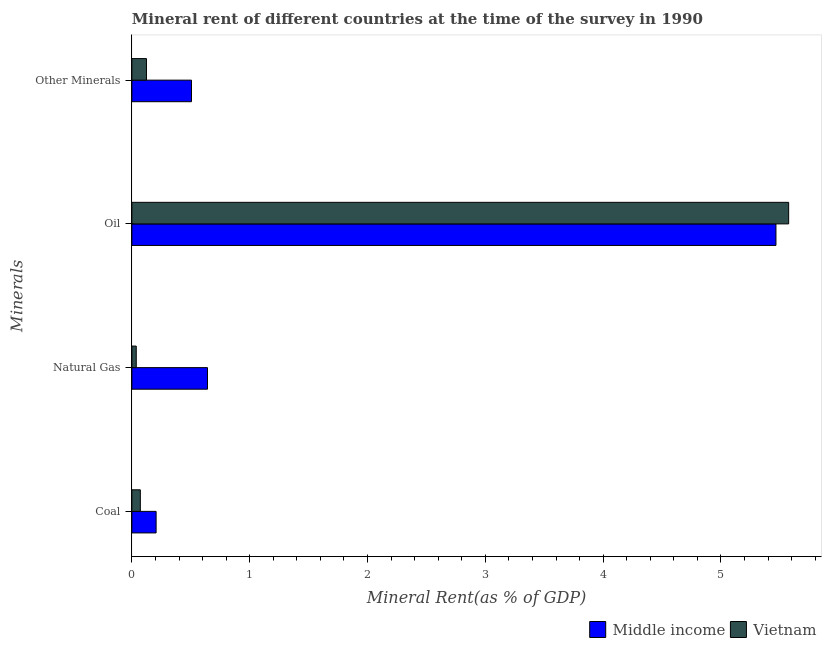Are the number of bars per tick equal to the number of legend labels?
Provide a succinct answer. Yes. Are the number of bars on each tick of the Y-axis equal?
Provide a succinct answer. Yes. What is the label of the 2nd group of bars from the top?
Provide a succinct answer. Oil. What is the  rent of other minerals in Vietnam?
Keep it short and to the point. 0.12. Across all countries, what is the maximum  rent of other minerals?
Your answer should be very brief. 0.51. Across all countries, what is the minimum coal rent?
Ensure brevity in your answer.  0.07. In which country was the coal rent maximum?
Give a very brief answer. Middle income. In which country was the natural gas rent minimum?
Offer a terse response. Vietnam. What is the total coal rent in the graph?
Keep it short and to the point. 0.28. What is the difference between the natural gas rent in Middle income and that in Vietnam?
Make the answer very short. 0.6. What is the difference between the natural gas rent in Middle income and the  rent of other minerals in Vietnam?
Provide a succinct answer. 0.52. What is the average  rent of other minerals per country?
Offer a terse response. 0.31. What is the difference between the  rent of other minerals and oil rent in Middle income?
Offer a terse response. -4.96. What is the ratio of the coal rent in Vietnam to that in Middle income?
Your answer should be very brief. 0.35. Is the coal rent in Middle income less than that in Vietnam?
Keep it short and to the point. No. Is the difference between the oil rent in Middle income and Vietnam greater than the difference between the coal rent in Middle income and Vietnam?
Ensure brevity in your answer.  No. What is the difference between the highest and the second highest oil rent?
Keep it short and to the point. 0.11. What is the difference between the highest and the lowest  rent of other minerals?
Offer a very short reply. 0.38. In how many countries, is the  rent of other minerals greater than the average  rent of other minerals taken over all countries?
Make the answer very short. 1. Is the sum of the coal rent in Middle income and Vietnam greater than the maximum  rent of other minerals across all countries?
Offer a very short reply. No. What does the 1st bar from the top in Other Minerals represents?
Offer a terse response. Vietnam. How many bars are there?
Keep it short and to the point. 8. Are all the bars in the graph horizontal?
Keep it short and to the point. Yes. What is the title of the graph?
Provide a short and direct response. Mineral rent of different countries at the time of the survey in 1990. Does "Bahrain" appear as one of the legend labels in the graph?
Keep it short and to the point. No. What is the label or title of the X-axis?
Offer a terse response. Mineral Rent(as % of GDP). What is the label or title of the Y-axis?
Your answer should be compact. Minerals. What is the Mineral Rent(as % of GDP) of Middle income in Coal?
Your answer should be very brief. 0.21. What is the Mineral Rent(as % of GDP) in Vietnam in Coal?
Your response must be concise. 0.07. What is the Mineral Rent(as % of GDP) in Middle income in Natural Gas?
Your answer should be compact. 0.64. What is the Mineral Rent(as % of GDP) of Vietnam in Natural Gas?
Offer a very short reply. 0.04. What is the Mineral Rent(as % of GDP) of Middle income in Oil?
Your answer should be very brief. 5.47. What is the Mineral Rent(as % of GDP) of Vietnam in Oil?
Give a very brief answer. 5.57. What is the Mineral Rent(as % of GDP) of Middle income in Other Minerals?
Give a very brief answer. 0.51. What is the Mineral Rent(as % of GDP) of Vietnam in Other Minerals?
Make the answer very short. 0.12. Across all Minerals, what is the maximum Mineral Rent(as % of GDP) of Middle income?
Make the answer very short. 5.47. Across all Minerals, what is the maximum Mineral Rent(as % of GDP) of Vietnam?
Your answer should be compact. 5.57. Across all Minerals, what is the minimum Mineral Rent(as % of GDP) in Middle income?
Provide a succinct answer. 0.21. Across all Minerals, what is the minimum Mineral Rent(as % of GDP) in Vietnam?
Offer a terse response. 0.04. What is the total Mineral Rent(as % of GDP) of Middle income in the graph?
Your answer should be compact. 6.82. What is the total Mineral Rent(as % of GDP) in Vietnam in the graph?
Ensure brevity in your answer.  5.81. What is the difference between the Mineral Rent(as % of GDP) of Middle income in Coal and that in Natural Gas?
Offer a very short reply. -0.44. What is the difference between the Mineral Rent(as % of GDP) of Vietnam in Coal and that in Natural Gas?
Provide a succinct answer. 0.03. What is the difference between the Mineral Rent(as % of GDP) of Middle income in Coal and that in Oil?
Offer a terse response. -5.26. What is the difference between the Mineral Rent(as % of GDP) in Vietnam in Coal and that in Oil?
Provide a short and direct response. -5.5. What is the difference between the Mineral Rent(as % of GDP) in Middle income in Coal and that in Other Minerals?
Offer a terse response. -0.3. What is the difference between the Mineral Rent(as % of GDP) in Vietnam in Coal and that in Other Minerals?
Offer a very short reply. -0.05. What is the difference between the Mineral Rent(as % of GDP) of Middle income in Natural Gas and that in Oil?
Provide a short and direct response. -4.83. What is the difference between the Mineral Rent(as % of GDP) in Vietnam in Natural Gas and that in Oil?
Offer a terse response. -5.54. What is the difference between the Mineral Rent(as % of GDP) in Middle income in Natural Gas and that in Other Minerals?
Make the answer very short. 0.14. What is the difference between the Mineral Rent(as % of GDP) in Vietnam in Natural Gas and that in Other Minerals?
Make the answer very short. -0.09. What is the difference between the Mineral Rent(as % of GDP) in Middle income in Oil and that in Other Minerals?
Your answer should be compact. 4.96. What is the difference between the Mineral Rent(as % of GDP) of Vietnam in Oil and that in Other Minerals?
Make the answer very short. 5.45. What is the difference between the Mineral Rent(as % of GDP) of Middle income in Coal and the Mineral Rent(as % of GDP) of Vietnam in Natural Gas?
Offer a very short reply. 0.17. What is the difference between the Mineral Rent(as % of GDP) of Middle income in Coal and the Mineral Rent(as % of GDP) of Vietnam in Oil?
Ensure brevity in your answer.  -5.37. What is the difference between the Mineral Rent(as % of GDP) in Middle income in Coal and the Mineral Rent(as % of GDP) in Vietnam in Other Minerals?
Give a very brief answer. 0.08. What is the difference between the Mineral Rent(as % of GDP) of Middle income in Natural Gas and the Mineral Rent(as % of GDP) of Vietnam in Oil?
Offer a very short reply. -4.93. What is the difference between the Mineral Rent(as % of GDP) of Middle income in Natural Gas and the Mineral Rent(as % of GDP) of Vietnam in Other Minerals?
Your answer should be compact. 0.52. What is the difference between the Mineral Rent(as % of GDP) of Middle income in Oil and the Mineral Rent(as % of GDP) of Vietnam in Other Minerals?
Offer a terse response. 5.34. What is the average Mineral Rent(as % of GDP) of Middle income per Minerals?
Ensure brevity in your answer.  1.71. What is the average Mineral Rent(as % of GDP) of Vietnam per Minerals?
Offer a terse response. 1.45. What is the difference between the Mineral Rent(as % of GDP) in Middle income and Mineral Rent(as % of GDP) in Vietnam in Coal?
Your answer should be compact. 0.13. What is the difference between the Mineral Rent(as % of GDP) of Middle income and Mineral Rent(as % of GDP) of Vietnam in Natural Gas?
Offer a very short reply. 0.6. What is the difference between the Mineral Rent(as % of GDP) of Middle income and Mineral Rent(as % of GDP) of Vietnam in Oil?
Keep it short and to the point. -0.11. What is the difference between the Mineral Rent(as % of GDP) in Middle income and Mineral Rent(as % of GDP) in Vietnam in Other Minerals?
Your response must be concise. 0.38. What is the ratio of the Mineral Rent(as % of GDP) of Middle income in Coal to that in Natural Gas?
Make the answer very short. 0.32. What is the ratio of the Mineral Rent(as % of GDP) of Vietnam in Coal to that in Natural Gas?
Ensure brevity in your answer.  1.93. What is the ratio of the Mineral Rent(as % of GDP) of Middle income in Coal to that in Oil?
Provide a succinct answer. 0.04. What is the ratio of the Mineral Rent(as % of GDP) of Vietnam in Coal to that in Oil?
Ensure brevity in your answer.  0.01. What is the ratio of the Mineral Rent(as % of GDP) in Middle income in Coal to that in Other Minerals?
Your answer should be compact. 0.41. What is the ratio of the Mineral Rent(as % of GDP) in Vietnam in Coal to that in Other Minerals?
Ensure brevity in your answer.  0.58. What is the ratio of the Mineral Rent(as % of GDP) in Middle income in Natural Gas to that in Oil?
Your answer should be very brief. 0.12. What is the ratio of the Mineral Rent(as % of GDP) in Vietnam in Natural Gas to that in Oil?
Your response must be concise. 0.01. What is the ratio of the Mineral Rent(as % of GDP) of Middle income in Natural Gas to that in Other Minerals?
Offer a very short reply. 1.27. What is the ratio of the Mineral Rent(as % of GDP) in Vietnam in Natural Gas to that in Other Minerals?
Offer a very short reply. 0.3. What is the ratio of the Mineral Rent(as % of GDP) in Middle income in Oil to that in Other Minerals?
Ensure brevity in your answer.  10.8. What is the ratio of the Mineral Rent(as % of GDP) in Vietnam in Oil to that in Other Minerals?
Ensure brevity in your answer.  44.99. What is the difference between the highest and the second highest Mineral Rent(as % of GDP) of Middle income?
Provide a succinct answer. 4.83. What is the difference between the highest and the second highest Mineral Rent(as % of GDP) in Vietnam?
Keep it short and to the point. 5.45. What is the difference between the highest and the lowest Mineral Rent(as % of GDP) in Middle income?
Ensure brevity in your answer.  5.26. What is the difference between the highest and the lowest Mineral Rent(as % of GDP) in Vietnam?
Your answer should be very brief. 5.54. 